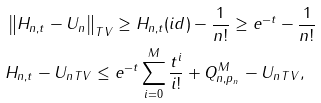Convert formula to latex. <formula><loc_0><loc_0><loc_500><loc_500>& \left \| H _ { n , t } - U _ { n } \right \| _ { T V } \geq H _ { n , t } ( i d ) - \frac { 1 } { n ! } \geq e ^ { - t } - \frac { 1 } { n ! } \\ & \| H _ { n , t } - U _ { n } \| _ { T V } \leq e ^ { - t } \sum _ { i = 0 } ^ { M } \frac { t ^ { i } } { i ! } + \| Q _ { n , p _ { n } } ^ { M } - U _ { n } \| _ { T V } ,</formula> 